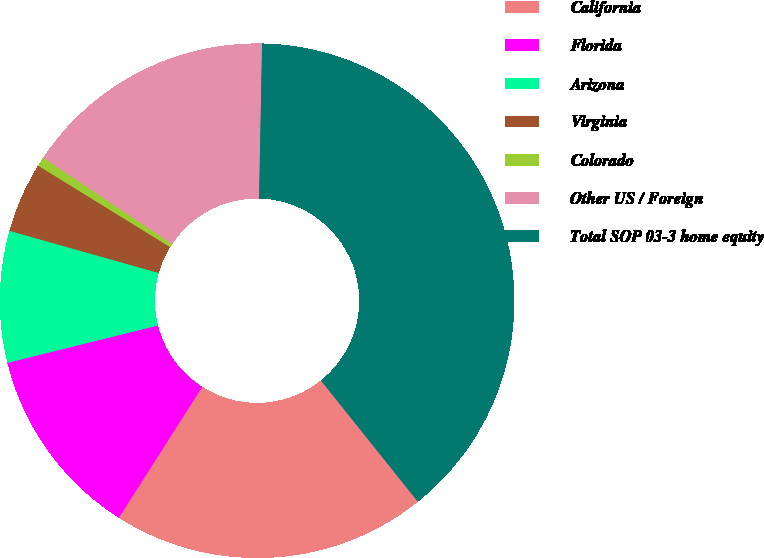Convert chart to OTSL. <chart><loc_0><loc_0><loc_500><loc_500><pie_chart><fcel>California<fcel>Florida<fcel>Arizona<fcel>Virginia<fcel>Colorado<fcel>Other US / Foreign<fcel>Total SOP 03-3 home equity<nl><fcel>19.77%<fcel>12.09%<fcel>8.26%<fcel>4.42%<fcel>0.58%<fcel>15.93%<fcel>38.95%<nl></chart> 